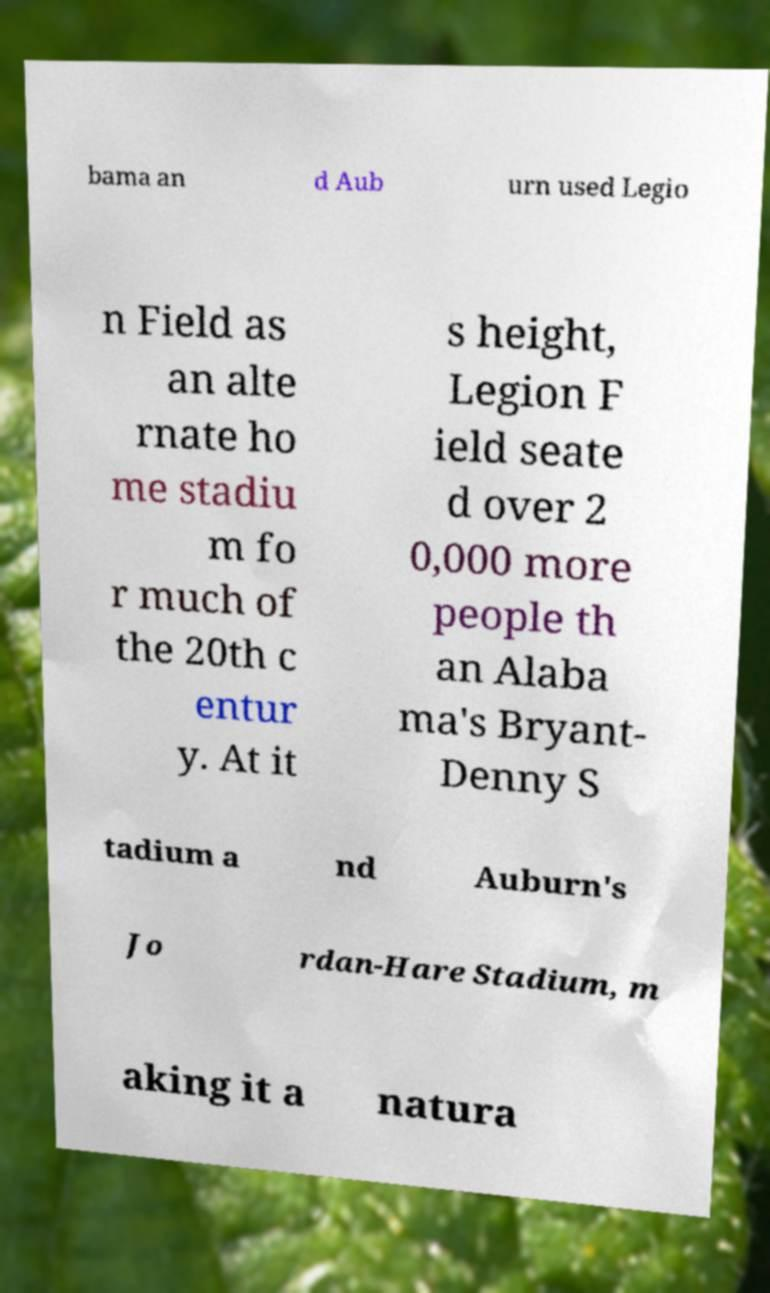Please read and relay the text visible in this image. What does it say? bama an d Aub urn used Legio n Field as an alte rnate ho me stadiu m fo r much of the 20th c entur y. At it s height, Legion F ield seate d over 2 0,000 more people th an Alaba ma's Bryant- Denny S tadium a nd Auburn's Jo rdan-Hare Stadium, m aking it a natura 